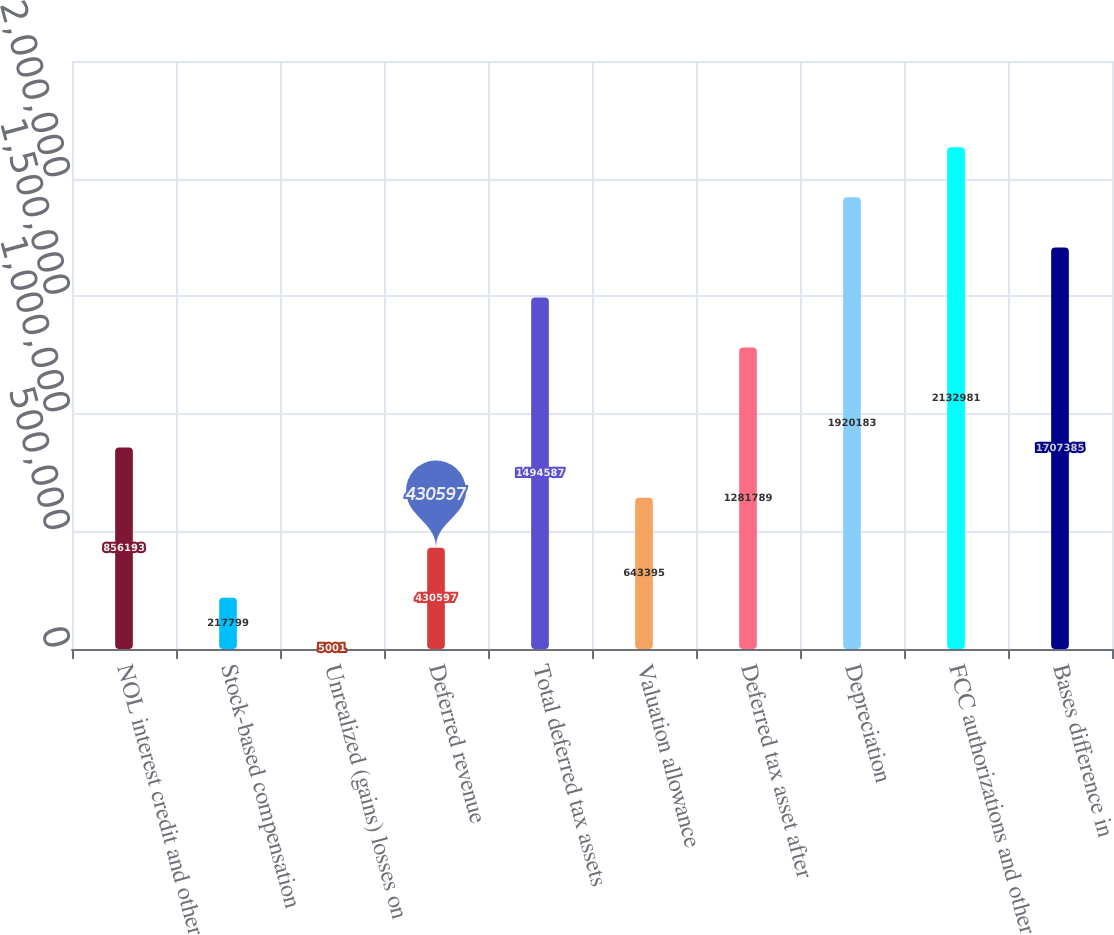Convert chart. <chart><loc_0><loc_0><loc_500><loc_500><bar_chart><fcel>NOL interest credit and other<fcel>Stock-based compensation<fcel>Unrealized (gains) losses on<fcel>Deferred revenue<fcel>Total deferred tax assets<fcel>Valuation allowance<fcel>Deferred tax asset after<fcel>Depreciation<fcel>FCC authorizations and other<fcel>Bases difference in<nl><fcel>856193<fcel>217799<fcel>5001<fcel>430597<fcel>1.49459e+06<fcel>643395<fcel>1.28179e+06<fcel>1.92018e+06<fcel>2.13298e+06<fcel>1.70738e+06<nl></chart> 